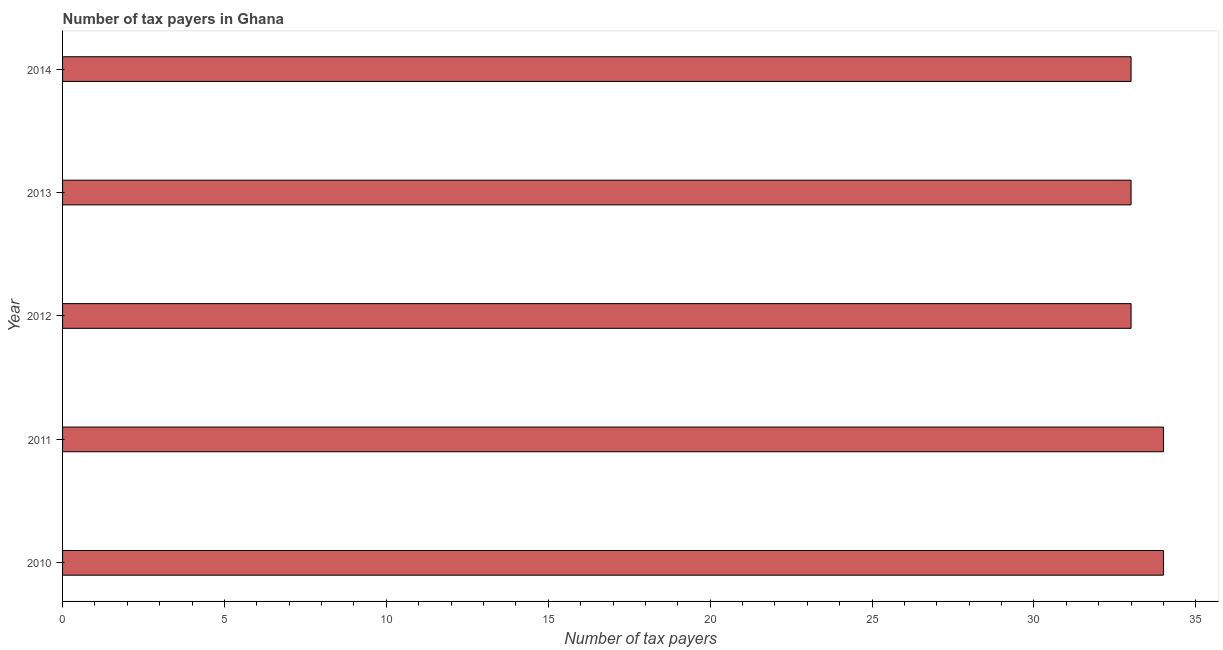Does the graph contain grids?
Provide a succinct answer. No. What is the title of the graph?
Provide a succinct answer. Number of tax payers in Ghana. What is the label or title of the X-axis?
Offer a terse response. Number of tax payers. What is the label or title of the Y-axis?
Keep it short and to the point. Year. What is the number of tax payers in 2010?
Offer a very short reply. 34. Across all years, what is the minimum number of tax payers?
Ensure brevity in your answer.  33. In which year was the number of tax payers minimum?
Your answer should be compact. 2012. What is the sum of the number of tax payers?
Ensure brevity in your answer.  167. What is the median number of tax payers?
Give a very brief answer. 33. In how many years, is the number of tax payers greater than 4 ?
Make the answer very short. 5. What is the ratio of the number of tax payers in 2011 to that in 2014?
Offer a terse response. 1.03. Is the difference between the number of tax payers in 2012 and 2014 greater than the difference between any two years?
Make the answer very short. No. Is the sum of the number of tax payers in 2011 and 2014 greater than the maximum number of tax payers across all years?
Your answer should be compact. Yes. What is the difference between the highest and the lowest number of tax payers?
Provide a short and direct response. 1. Are all the bars in the graph horizontal?
Your answer should be very brief. Yes. Are the values on the major ticks of X-axis written in scientific E-notation?
Your answer should be compact. No. What is the Number of tax payers of 2011?
Make the answer very short. 34. What is the Number of tax payers in 2013?
Your answer should be compact. 33. What is the difference between the Number of tax payers in 2010 and 2011?
Your response must be concise. 0. What is the difference between the Number of tax payers in 2010 and 2013?
Offer a very short reply. 1. What is the difference between the Number of tax payers in 2011 and 2014?
Your response must be concise. 1. What is the difference between the Number of tax payers in 2012 and 2013?
Offer a terse response. 0. What is the ratio of the Number of tax payers in 2010 to that in 2011?
Your answer should be compact. 1. What is the ratio of the Number of tax payers in 2010 to that in 2012?
Your response must be concise. 1.03. What is the ratio of the Number of tax payers in 2010 to that in 2014?
Your answer should be very brief. 1.03. What is the ratio of the Number of tax payers in 2011 to that in 2012?
Keep it short and to the point. 1.03. What is the ratio of the Number of tax payers in 2011 to that in 2013?
Provide a short and direct response. 1.03. What is the ratio of the Number of tax payers in 2012 to that in 2013?
Your answer should be compact. 1. What is the ratio of the Number of tax payers in 2012 to that in 2014?
Keep it short and to the point. 1. What is the ratio of the Number of tax payers in 2013 to that in 2014?
Give a very brief answer. 1. 